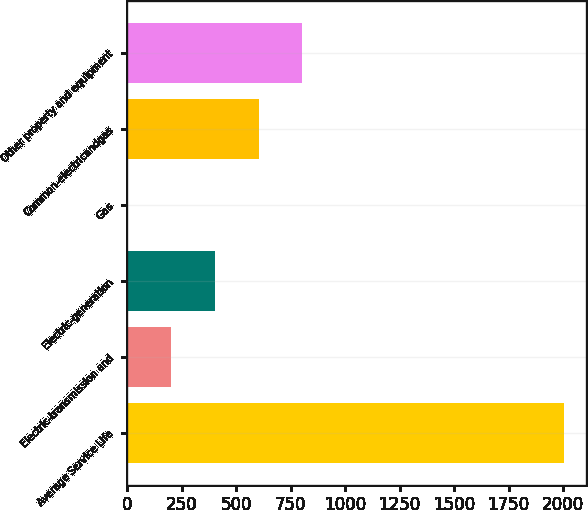<chart> <loc_0><loc_0><loc_500><loc_500><bar_chart><fcel>Average Service Life<fcel>Electric-transmission and<fcel>Electric-generation<fcel>Gas<fcel>Common-electricandgas<fcel>Other property and equipment<nl><fcel>2004<fcel>202.67<fcel>402.82<fcel>2.52<fcel>602.97<fcel>803.12<nl></chart> 